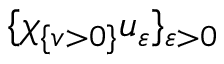<formula> <loc_0><loc_0><loc_500><loc_500>\{ \chi _ { \{ v > 0 \} } u _ { \varepsilon } \} _ { \varepsilon > 0 }</formula> 